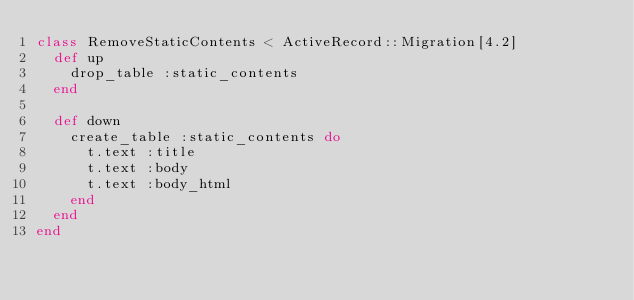Convert code to text. <code><loc_0><loc_0><loc_500><loc_500><_Ruby_>class RemoveStaticContents < ActiveRecord::Migration[4.2]
  def up
    drop_table :static_contents
  end

  def down
    create_table :static_contents do
      t.text :title
      t.text :body
      t.text :body_html
    end
  end
end
</code> 